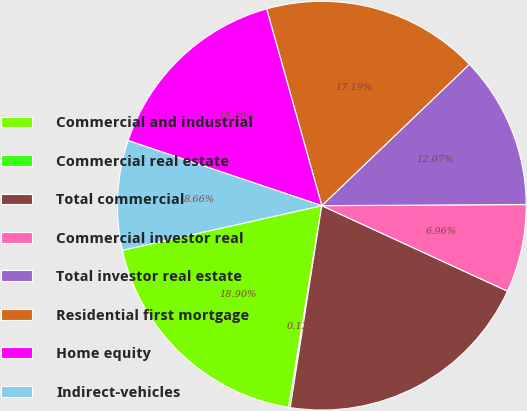<chart> <loc_0><loc_0><loc_500><loc_500><pie_chart><fcel>Commercial and industrial<fcel>Commercial real estate<fcel>Total commercial<fcel>Commercial investor real<fcel>Total investor real estate<fcel>Residential first mortgage<fcel>Home equity<fcel>Indirect-vehicles<nl><fcel>18.9%<fcel>0.13%<fcel>20.6%<fcel>6.96%<fcel>12.07%<fcel>17.19%<fcel>15.49%<fcel>8.66%<nl></chart> 